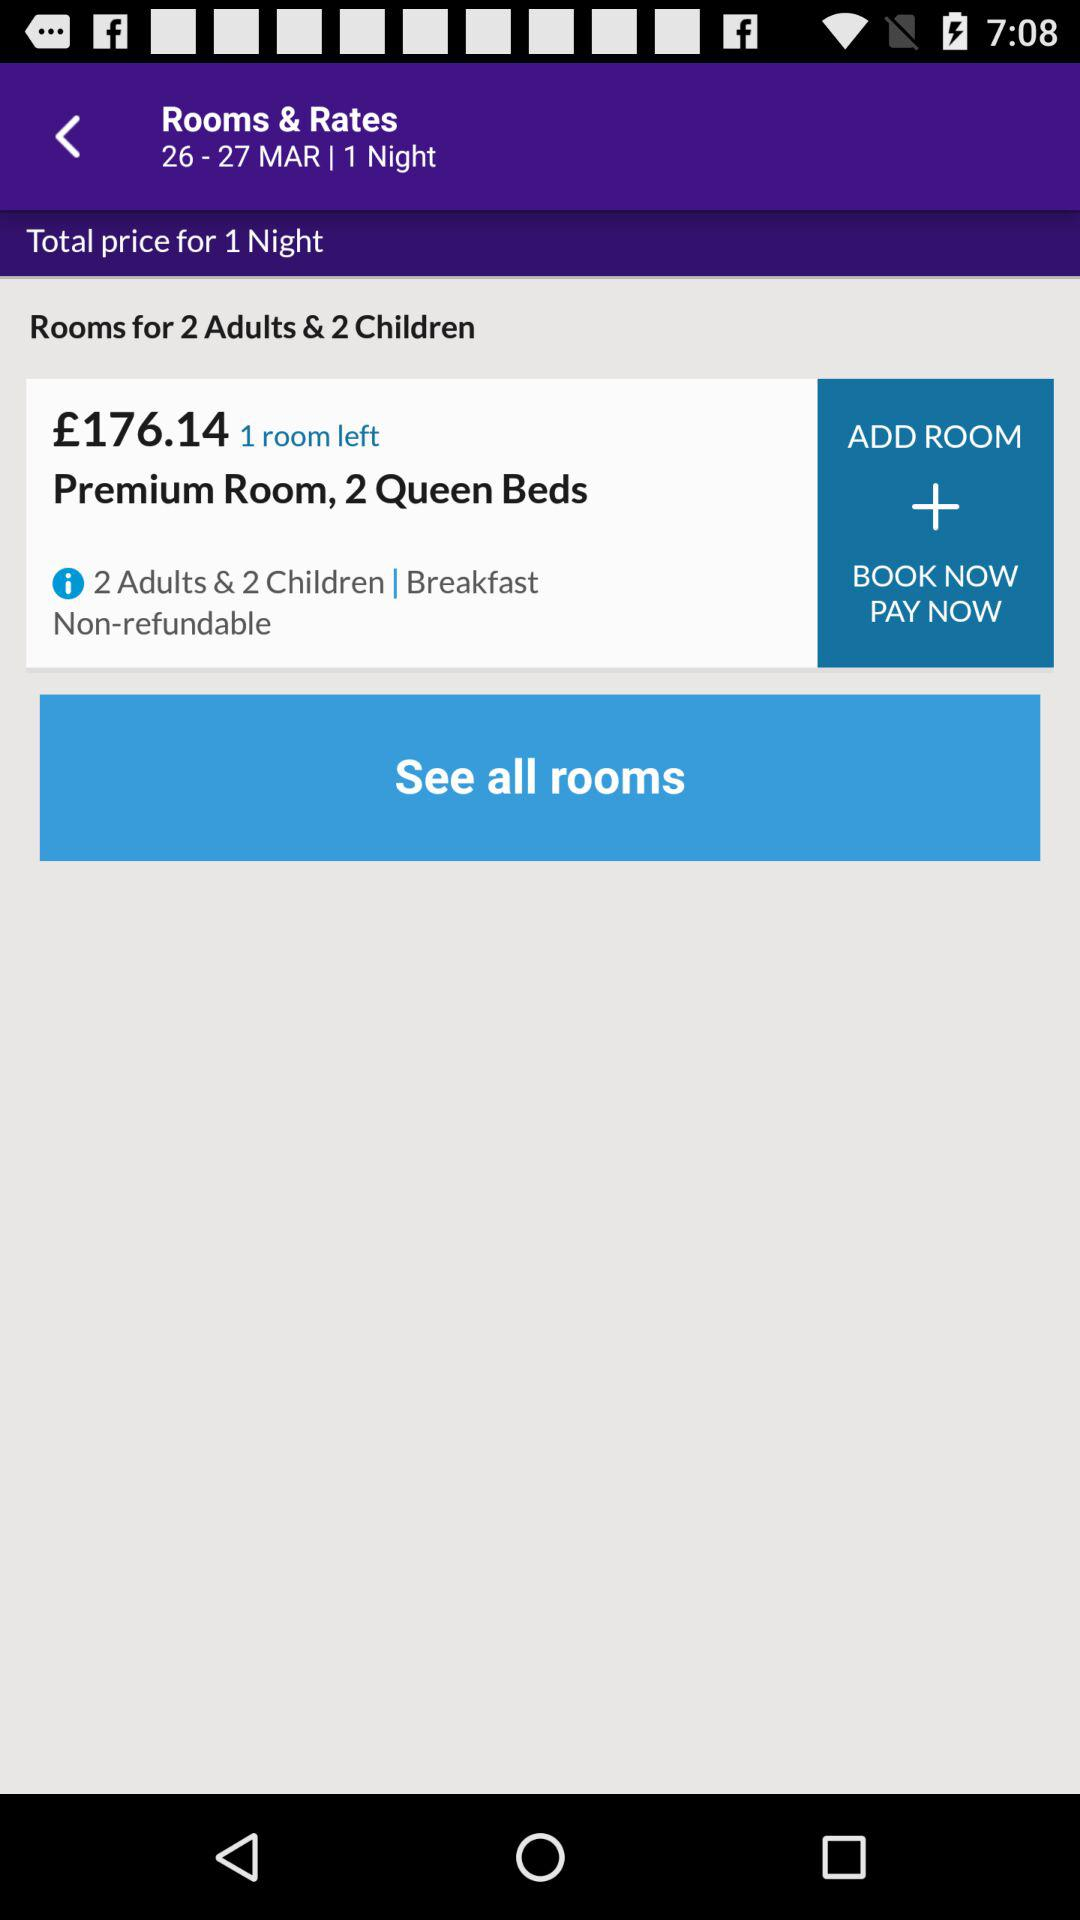How many rooms are available?
Answer the question using a single word or phrase. 1 